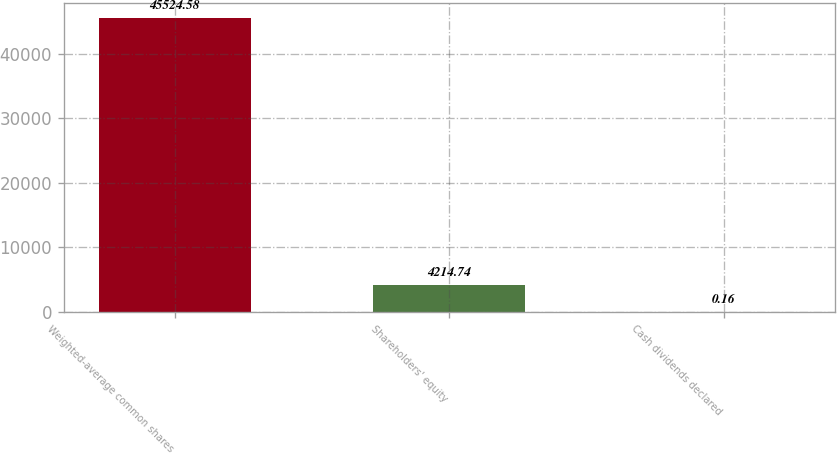Convert chart. <chart><loc_0><loc_0><loc_500><loc_500><bar_chart><fcel>Weighted-average common shares<fcel>Shareholders' equity<fcel>Cash dividends declared<nl><fcel>45524.6<fcel>4214.74<fcel>0.16<nl></chart> 